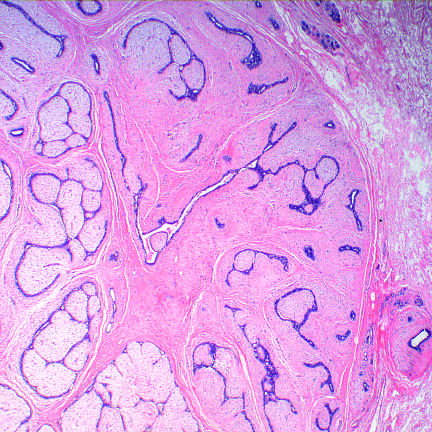does this benign tumor have an expansile growth pattern with pushing circumscribed borders?
Answer the question using a single word or phrase. Yes 